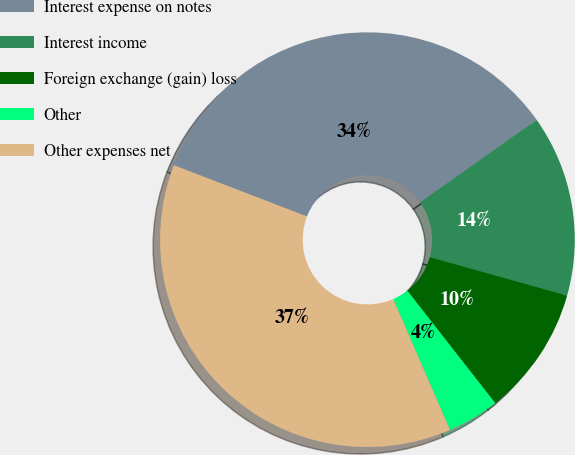Convert chart. <chart><loc_0><loc_0><loc_500><loc_500><pie_chart><fcel>Interest expense on notes<fcel>Interest income<fcel>Foreign exchange (gain) loss<fcel>Other<fcel>Other expenses net<nl><fcel>34.34%<fcel>14.14%<fcel>10.1%<fcel>4.04%<fcel>37.37%<nl></chart> 